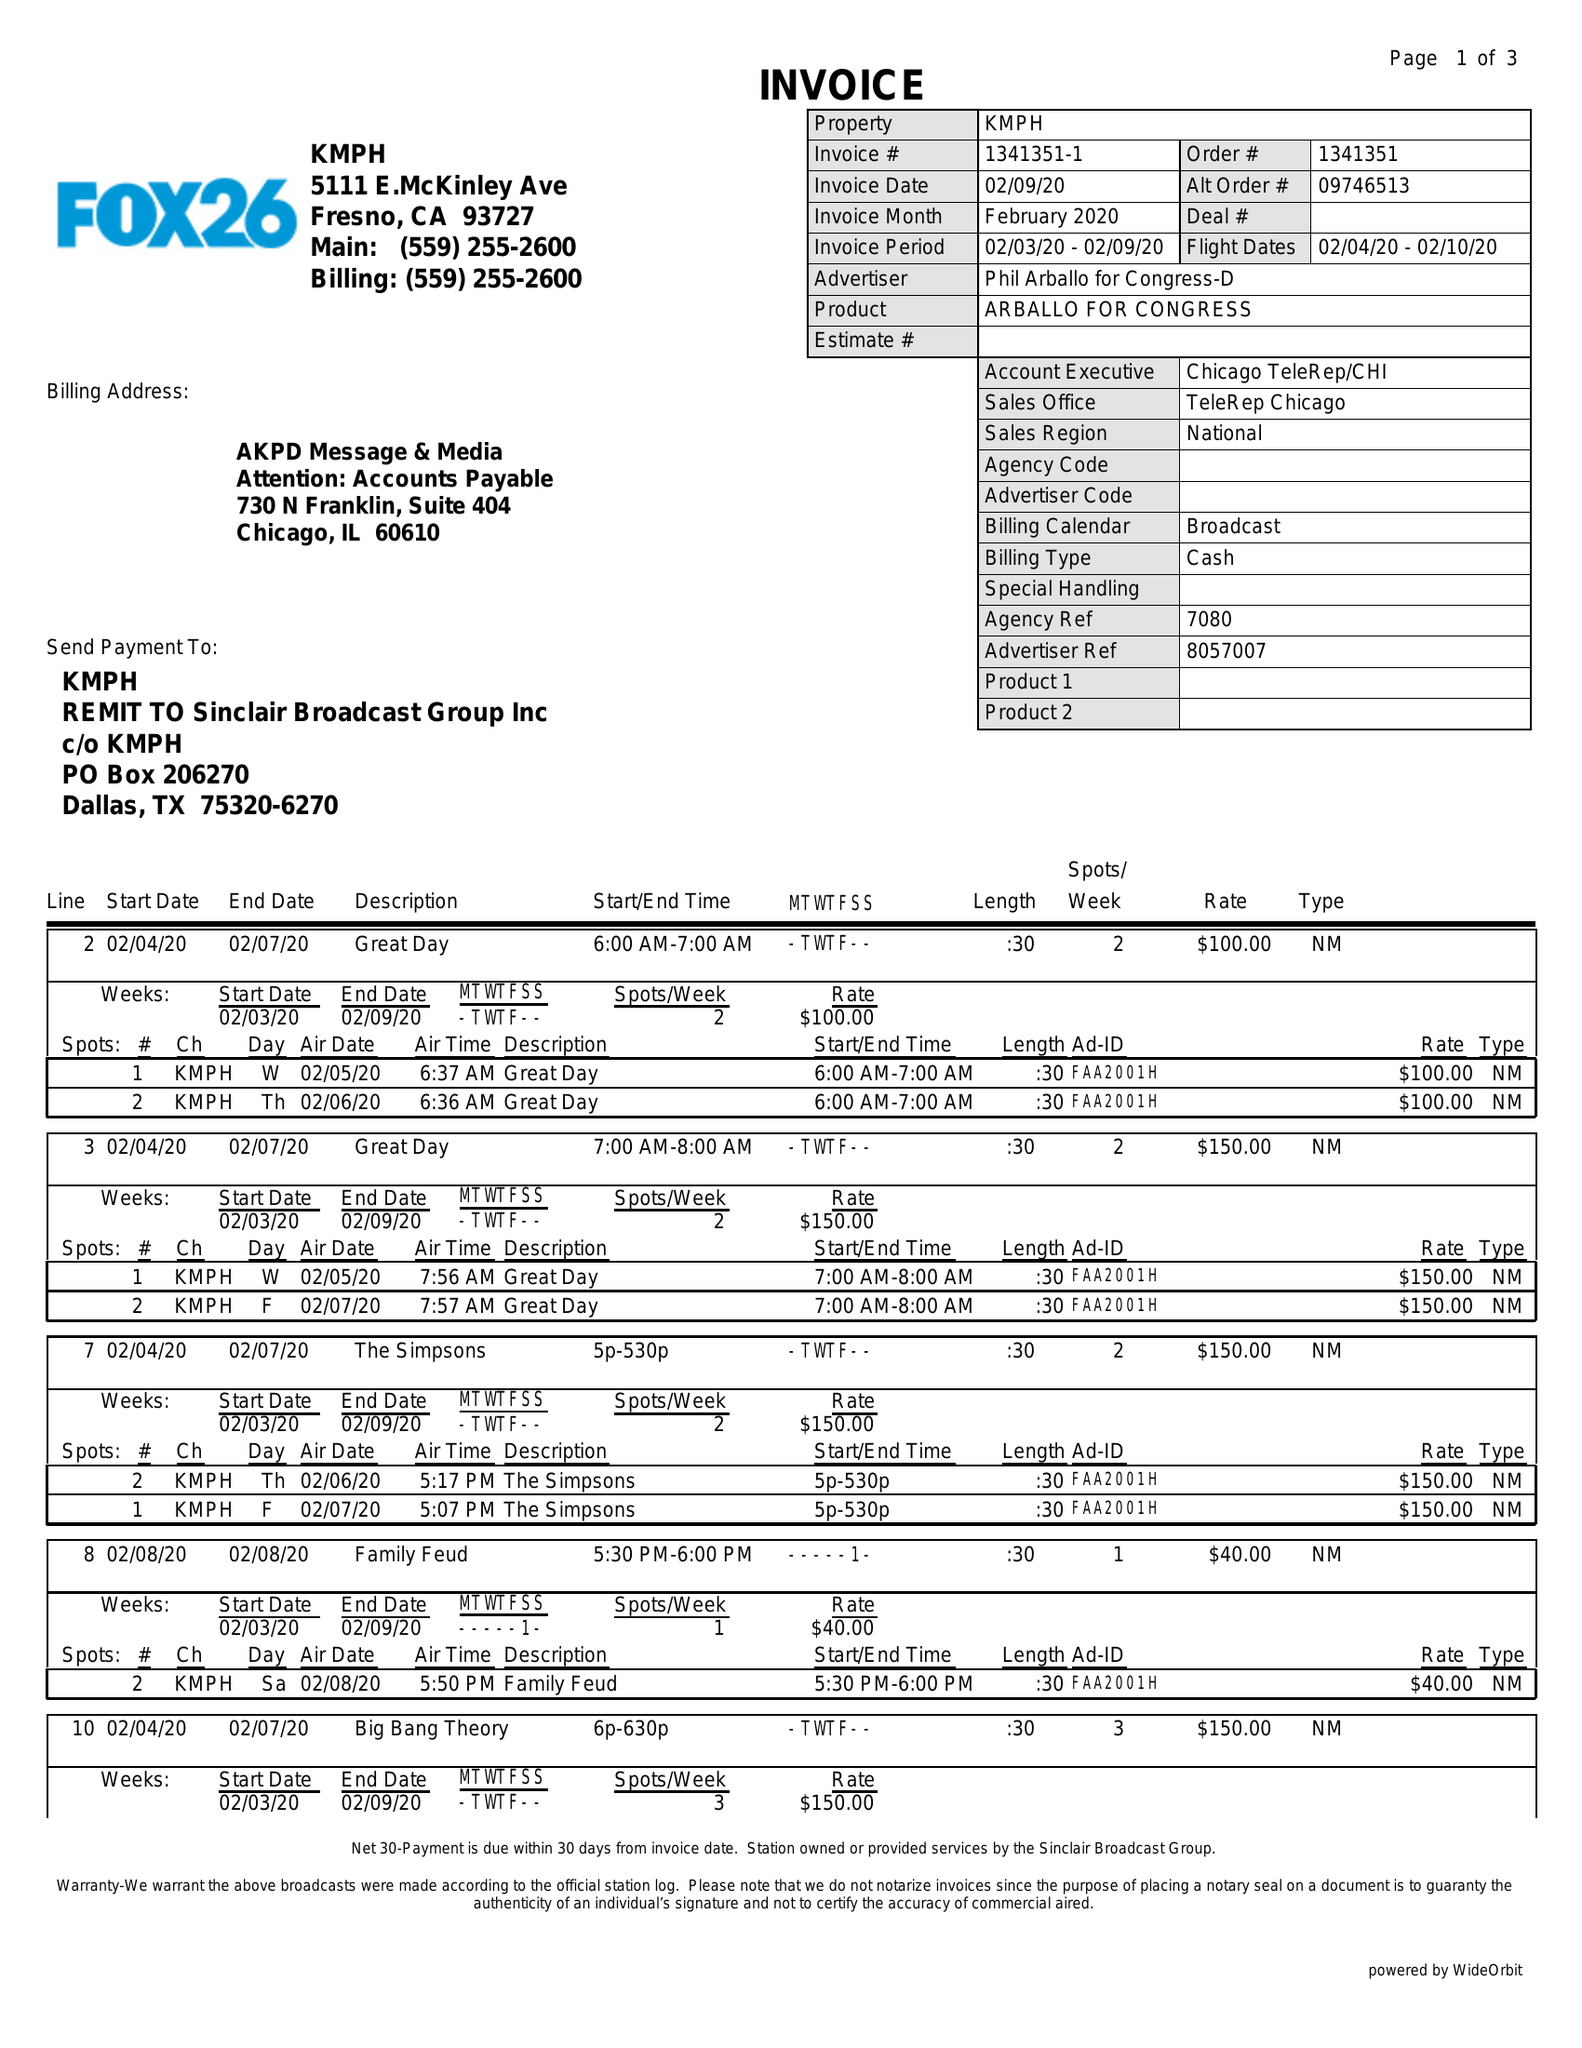What is the value for the advertiser?
Answer the question using a single word or phrase. PHIL ARBALLO FOR CONGRESS-D 